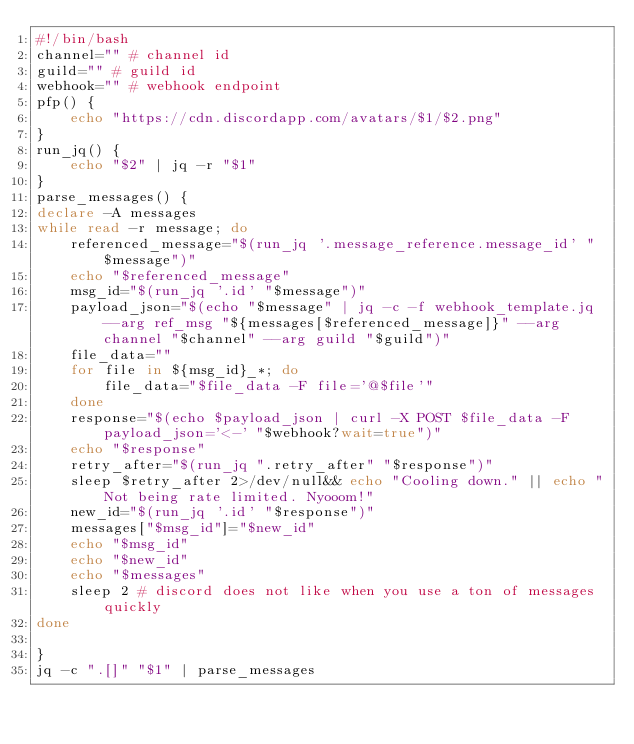<code> <loc_0><loc_0><loc_500><loc_500><_Bash_>#!/bin/bash
channel="" # channel id
guild="" # guild id
webhook="" # webhook endpoint
pfp() {
	echo "https://cdn.discordapp.com/avatars/$1/$2.png"
}
run_jq() {
	echo "$2" | jq -r "$1"
}
parse_messages() {
declare -A messages
while read -r message; do
	referenced_message="$(run_jq '.message_reference.message_id' "$message")"
	echo "$referenced_message"
	msg_id="$(run_jq '.id' "$message")"
	payload_json="$(echo "$message" | jq -c -f webhook_template.jq --arg ref_msg "${messages[$referenced_message]}" --arg channel "$channel" --arg guild "$guild")"
	file_data=""
	for file in ${msg_id}_*; do
		file_data="$file_data -F file='@$file'"
	done
	response="$(echo $payload_json | curl -X POST $file_data -F payload_json='<-' "$webhook?wait=true")"
	echo "$response"
	retry_after="$(run_jq ".retry_after" "$response")"
	sleep $retry_after 2>/dev/null&& echo "Cooling down." || echo "Not being rate limited. Nyooom!"
	new_id="$(run_jq '.id' "$response")"
	messages["$msg_id"]="$new_id"
	echo "$msg_id"
	echo "$new_id"
	echo "$messages"
	sleep 2 # discord does not like when you use a ton of messages quickly
done

}
jq -c ".[]" "$1" | parse_messages
</code> 